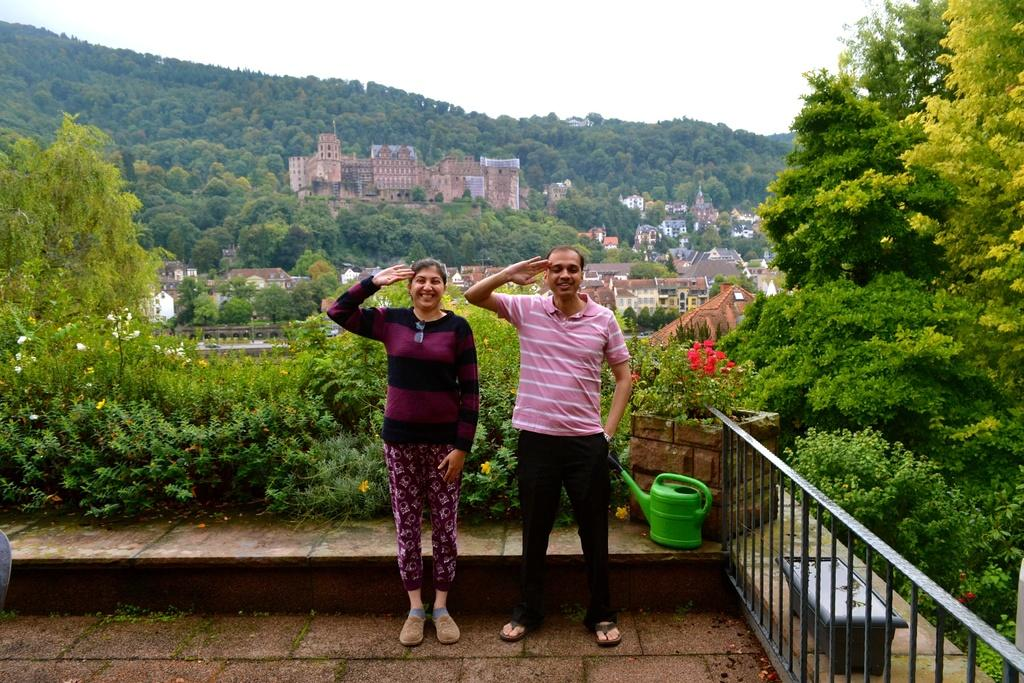How many people are present in the image? There are two people, a man and a woman, present in the image. What are the man and woman doing in the image? Both the man and woman are standing on the floor. What object can be seen in the image that is typically used for watering plants? There is a watering can in the image. What architectural feature is present in the image? There are railings in the image. What type of vegetation can be seen in the image? There are plants, shrubs, and trees in the image. What type of natural landscape can be seen in the image? There are hills in the image. What part of the natural environment is visible in the image? The sky is visible in the image. How many bears are visible in the image? There are no bears present in the image. What type of chin can be seen on the man in the image? There is no chin visible on the man in the image, as the image does not show the man's face. 